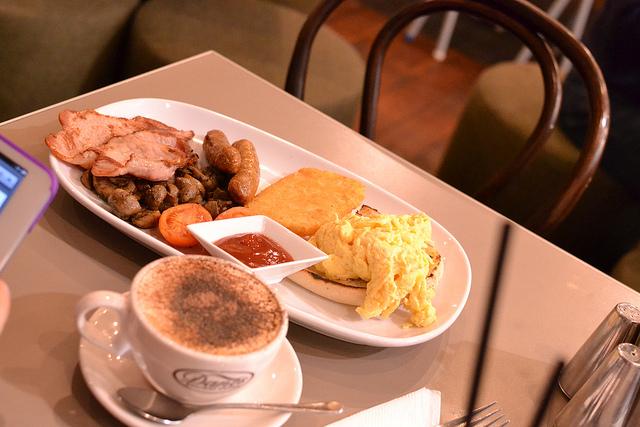What is in the white cup?
Short answer required. Coffee. Is there anyone eating?
Write a very short answer. No. Where is the ketchup?
Short answer required. Little bowl. 